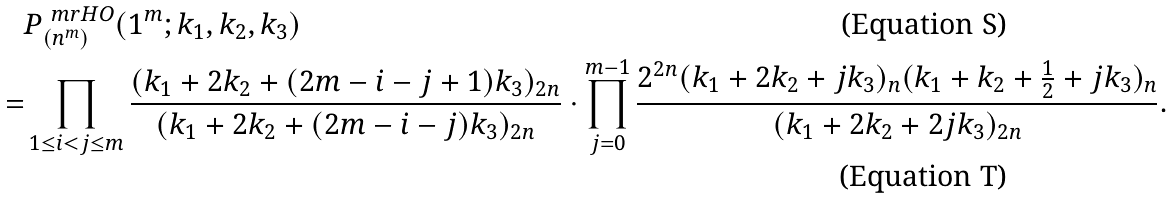<formula> <loc_0><loc_0><loc_500><loc_500>& P ^ { \ m r { H O } } _ { ( n ^ { m } ) } ( 1 ^ { m } ; k _ { 1 } , k _ { 2 } , k _ { 3 } ) \\ = & \prod _ { 1 \leq i < j \leq m } \frac { ( k _ { 1 } + 2 k _ { 2 } + ( 2 m - i - j + 1 ) k _ { 3 } ) _ { 2 n } } { ( k _ { 1 } + 2 k _ { 2 } + ( 2 m - i - j ) k _ { 3 } ) _ { 2 n } } \cdot \prod _ { j = 0 } ^ { m - 1 } \frac { 2 ^ { 2 n } ( k _ { 1 } + 2 k _ { 2 } + j k _ { 3 } ) _ { n } ( k _ { 1 } + k _ { 2 } + \frac { 1 } { 2 } + j k _ { 3 } ) _ { n } } { ( k _ { 1 } + 2 k _ { 2 } + 2 j k _ { 3 } ) _ { 2 n } } .</formula> 